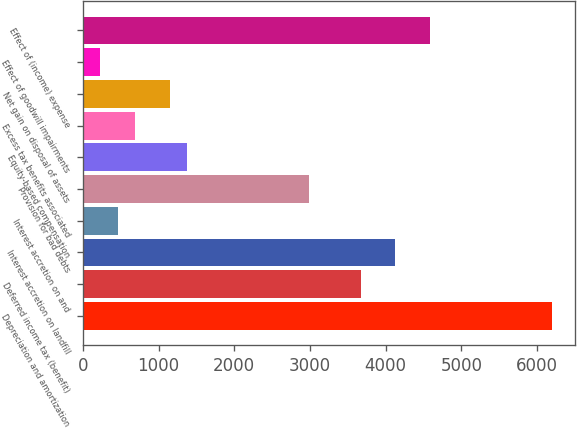Convert chart to OTSL. <chart><loc_0><loc_0><loc_500><loc_500><bar_chart><fcel>Depreciation and amortization<fcel>Deferred income tax (benefit)<fcel>Interest accretion on landfill<fcel>Interest accretion on and<fcel>Provision for bad debts<fcel>Equity-based compensation<fcel>Excess tax benefits associated<fcel>Net gain on disposal of assets<fcel>Effect of goodwill impairments<fcel>Effect of (income) expense<nl><fcel>6194.8<fcel>3671.4<fcel>4130.2<fcel>459.8<fcel>2983.2<fcel>1377.4<fcel>689.2<fcel>1148<fcel>230.4<fcel>4589<nl></chart> 